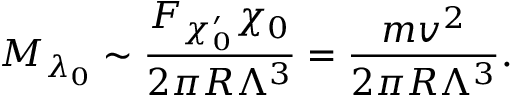<formula> <loc_0><loc_0><loc_500><loc_500>M _ { \lambda _ { 0 } } \sim { \frac { F _ { \chi _ { 0 } ^ { \prime } } \chi _ { 0 } } { 2 \pi R \Lambda ^ { 3 } } } = { \frac { m v ^ { 2 } } { 2 \pi R \Lambda ^ { 3 } } } .</formula> 